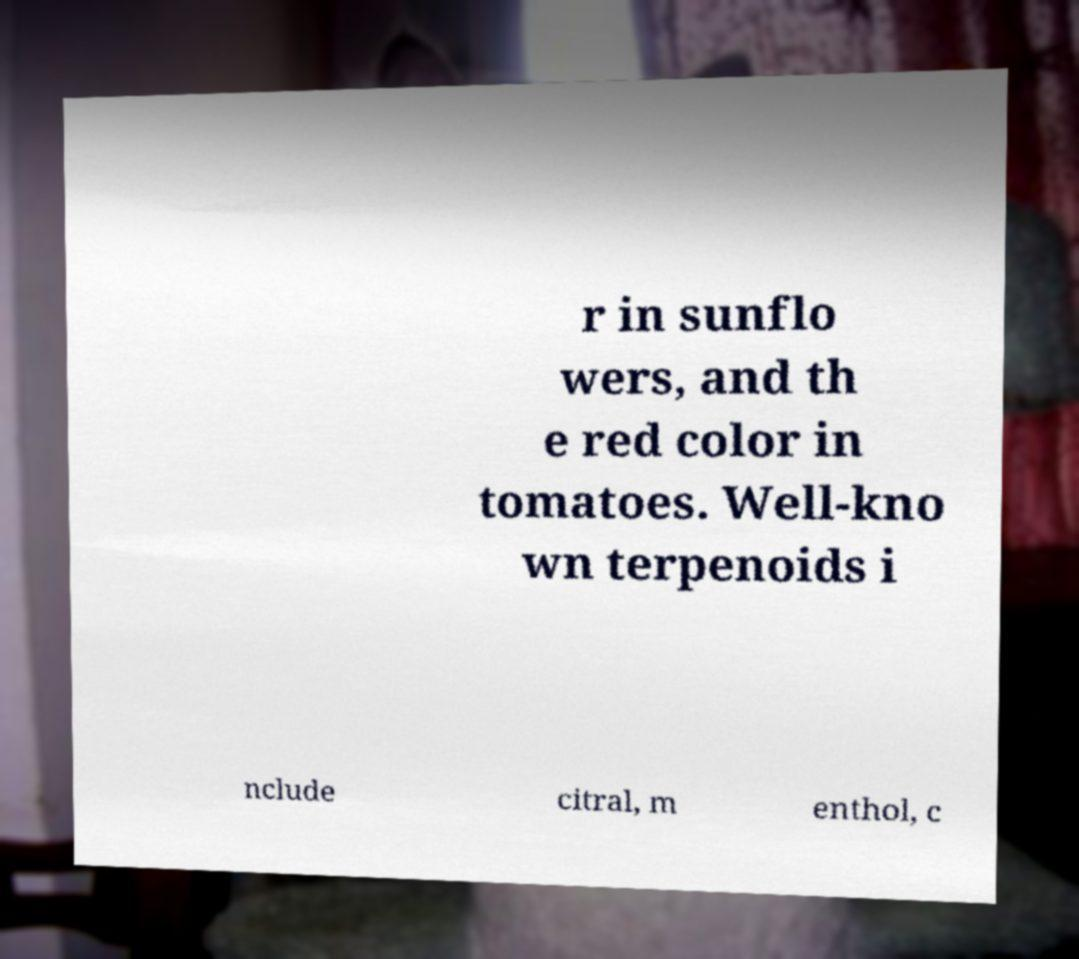I need the written content from this picture converted into text. Can you do that? r in sunflo wers, and th e red color in tomatoes. Well-kno wn terpenoids i nclude citral, m enthol, c 